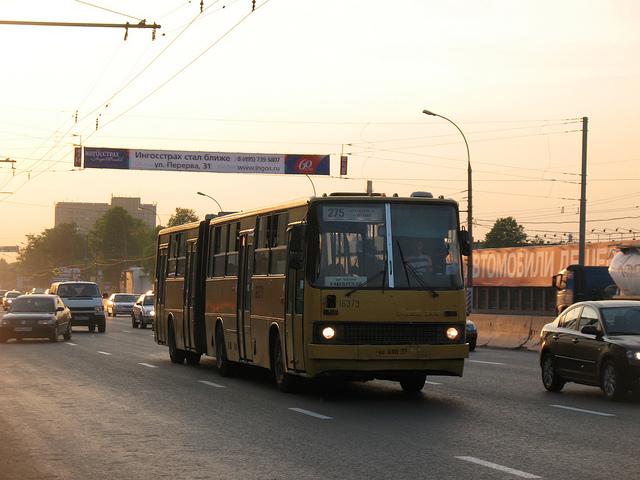Is the traffic moving?
Quick response, please. Yes. What color is the bus?
Be succinct. Yellow. What number is on the top of the bus?
Keep it brief. 275. Is this in the United States?
Be succinct. No. 